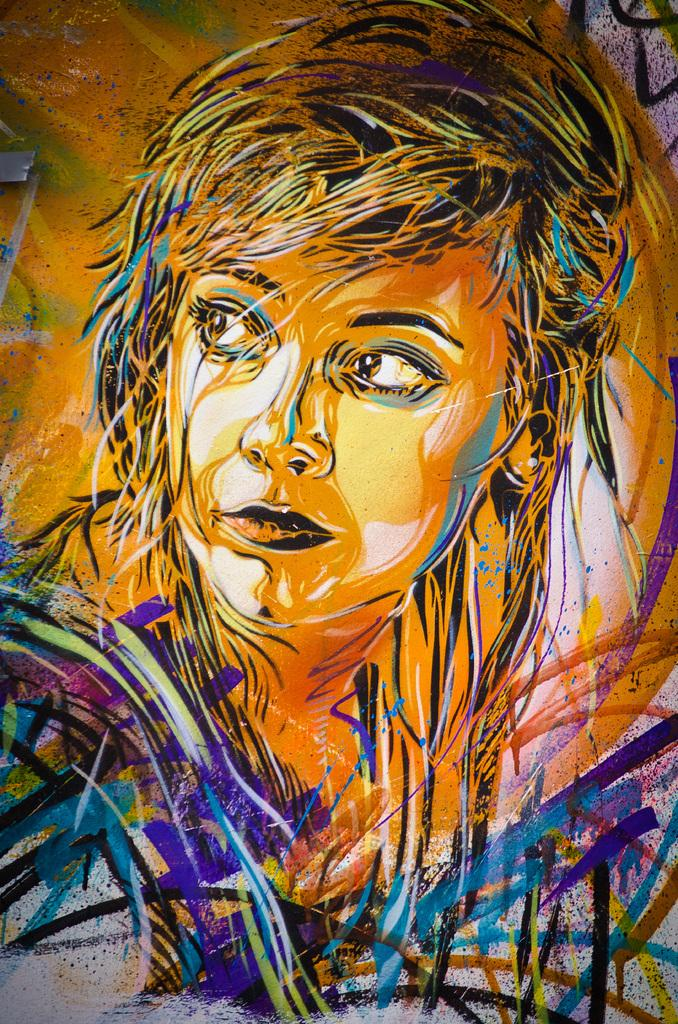What is the main subject of the picture? The main subject of the picture is an image of a woman. Where is the image of the woman located? The image of the woman is on a surface. What color is the surface where the image is located? The surface has a yellow color. What other colors are present in the image of the woman? The image of the woman includes a few more colors. How many rabbits are visible in the image? There are no rabbits present in the image; it features an image of a woman on a yellow surface. What type of kitty can be seen playing with clouds in the image? There is no kitty or clouds present in the image. 